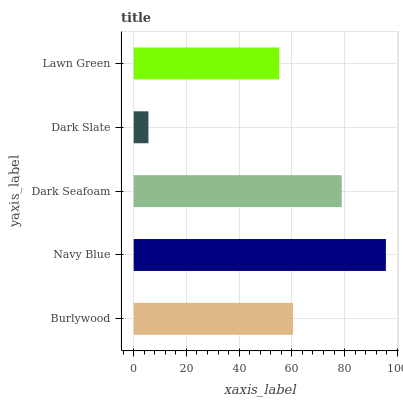Is Dark Slate the minimum?
Answer yes or no. Yes. Is Navy Blue the maximum?
Answer yes or no. Yes. Is Dark Seafoam the minimum?
Answer yes or no. No. Is Dark Seafoam the maximum?
Answer yes or no. No. Is Navy Blue greater than Dark Seafoam?
Answer yes or no. Yes. Is Dark Seafoam less than Navy Blue?
Answer yes or no. Yes. Is Dark Seafoam greater than Navy Blue?
Answer yes or no. No. Is Navy Blue less than Dark Seafoam?
Answer yes or no. No. Is Burlywood the high median?
Answer yes or no. Yes. Is Burlywood the low median?
Answer yes or no. Yes. Is Dark Slate the high median?
Answer yes or no. No. Is Lawn Green the low median?
Answer yes or no. No. 